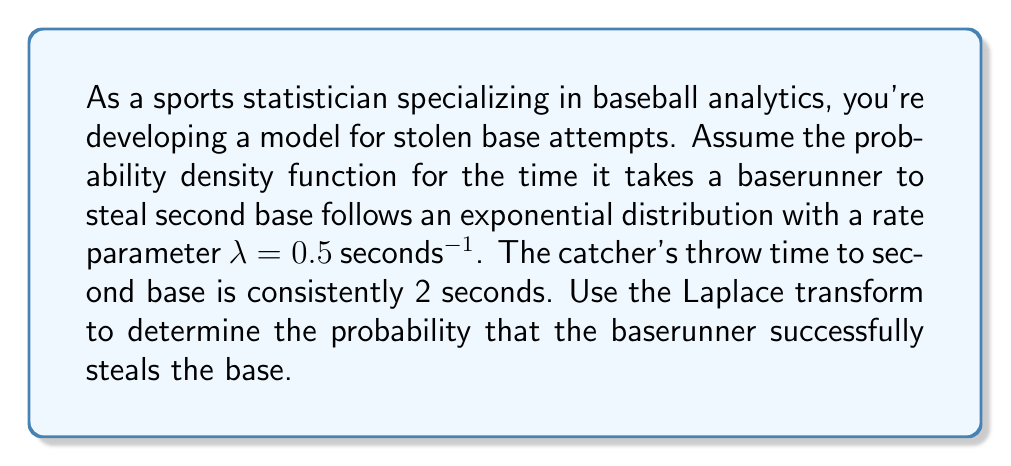Help me with this question. Let's approach this step-by-step using Laplace transforms:

1) The exponential distribution for the baserunner's time is given by:
   $$f(t) = \lambda e^{-\lambda t}, \quad t \geq 0$$

2) The Laplace transform of $f(t)$ is:
   $$F(s) = \mathcal{L}\{f(t)\} = \int_0^{\infty} e^{-st} \lambda e^{-\lambda t} dt = \frac{\lambda}{s + \lambda}$$

3) The probability of a successful steal is the probability that the runner's time is less than the catcher's throw time (2 seconds). In the time domain, this would be:
   $$P(\text{successful steal}) = \int_0^2 f(t) dt$$

4) Using the Laplace transform, we can express this as:
   $$P(\text{successful steal}) = 1 - \mathcal{L}^{-1}\left\{\frac{F(s)}{s} e^{-2s}\right\}_{t=0}$$

5) Substituting $F(s) = \frac{\lambda}{s + \lambda}$:
   $$P(\text{successful steal}) = 1 - \mathcal{L}^{-1}\left\{\frac{\lambda}{s(s + \lambda)} e^{-2s}\right\}_{t=0}$$

6) The inverse Laplace transform of this expression evaluated at $t=0$ is:
   $$1 - e^{-\lambda \cdot 2}$$

7) Substituting $\lambda = 0.5$:
   $$P(\text{successful steal}) = 1 - e^{-0.5 \cdot 2} = 1 - e^{-1}$$

8) Evaluating this expression:
   $$P(\text{successful steal}) = 1 - \frac{1}{e} \approx 0.6321$$

Therefore, the probability of a successful stolen base attempt is approximately 0.6321 or 63.21%.
Answer: The probability of a successful stolen base attempt is $1 - e^{-1} \approx 0.6321$ or 63.21%. 